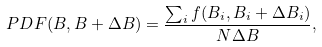Convert formula to latex. <formula><loc_0><loc_0><loc_500><loc_500>P D F ( B , B + \Delta B ) = \frac { \sum _ { i } f ( B _ { i } , B _ { i } + \Delta B _ { i } ) } { N \Delta B } ,</formula> 